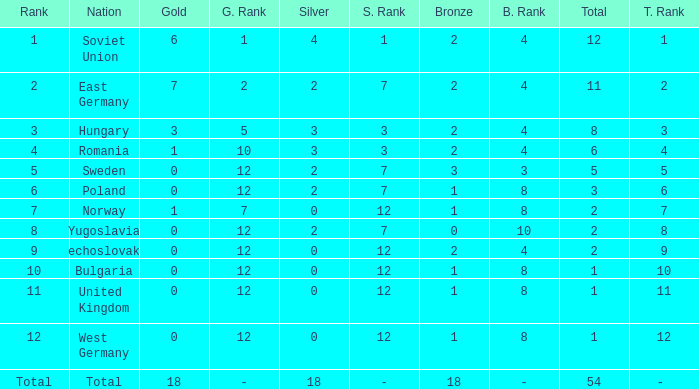What's the total of rank number 6 with more than 2 silver? None. 